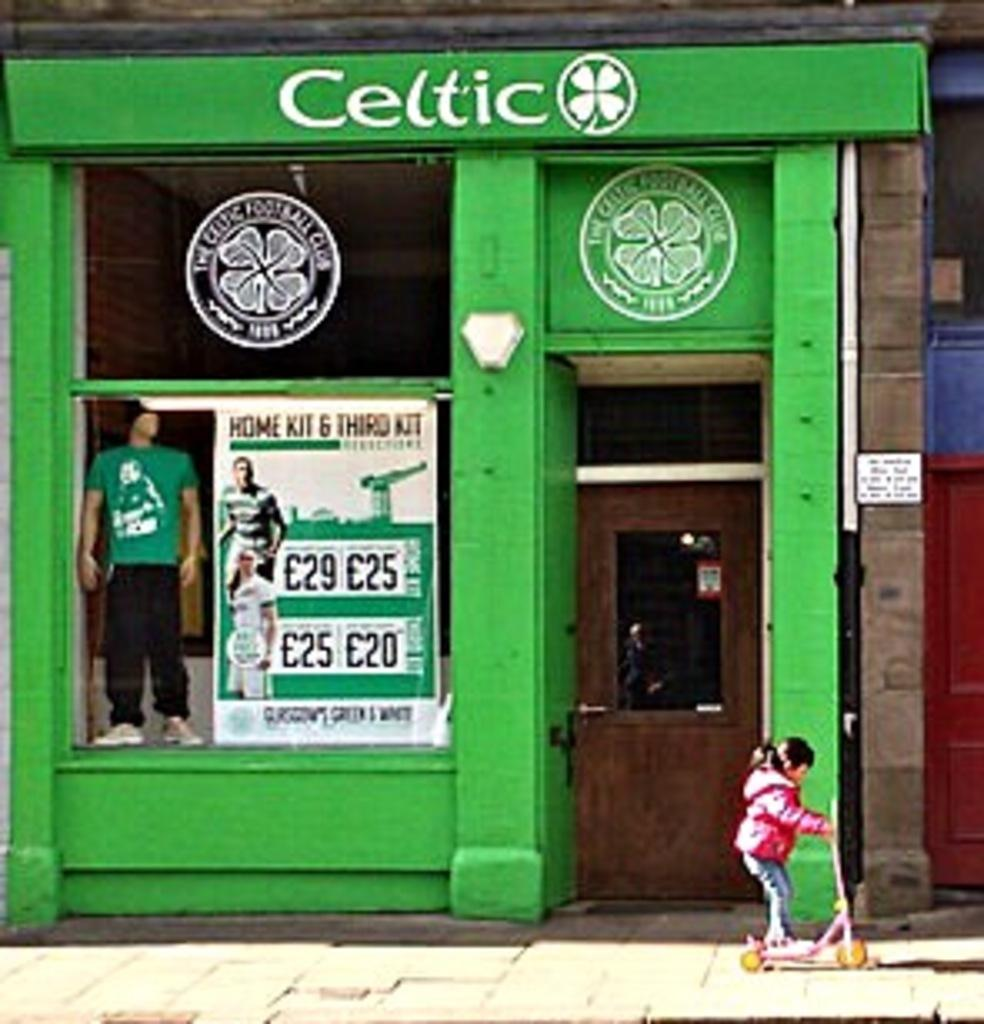<image>
Describe the image concisely. A bright green storefront for the Celtic football club. 